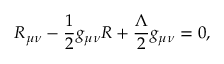<formula> <loc_0><loc_0><loc_500><loc_500>R _ { \mu \nu } - \frac { 1 } { 2 } g _ { \mu \nu } R + \frac { \Lambda } { 2 } g _ { \mu \nu } = 0 ,</formula> 